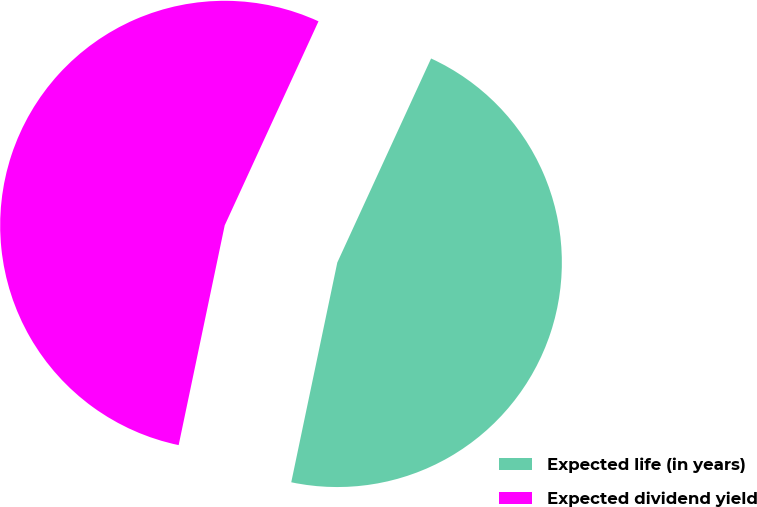Convert chart to OTSL. <chart><loc_0><loc_0><loc_500><loc_500><pie_chart><fcel>Expected life (in years)<fcel>Expected dividend yield<nl><fcel>46.43%<fcel>53.57%<nl></chart> 